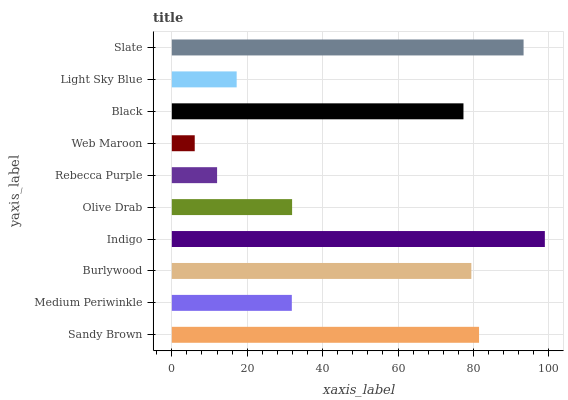Is Web Maroon the minimum?
Answer yes or no. Yes. Is Indigo the maximum?
Answer yes or no. Yes. Is Medium Periwinkle the minimum?
Answer yes or no. No. Is Medium Periwinkle the maximum?
Answer yes or no. No. Is Sandy Brown greater than Medium Periwinkle?
Answer yes or no. Yes. Is Medium Periwinkle less than Sandy Brown?
Answer yes or no. Yes. Is Medium Periwinkle greater than Sandy Brown?
Answer yes or no. No. Is Sandy Brown less than Medium Periwinkle?
Answer yes or no. No. Is Black the high median?
Answer yes or no. Yes. Is Olive Drab the low median?
Answer yes or no. Yes. Is Medium Periwinkle the high median?
Answer yes or no. No. Is Burlywood the low median?
Answer yes or no. No. 